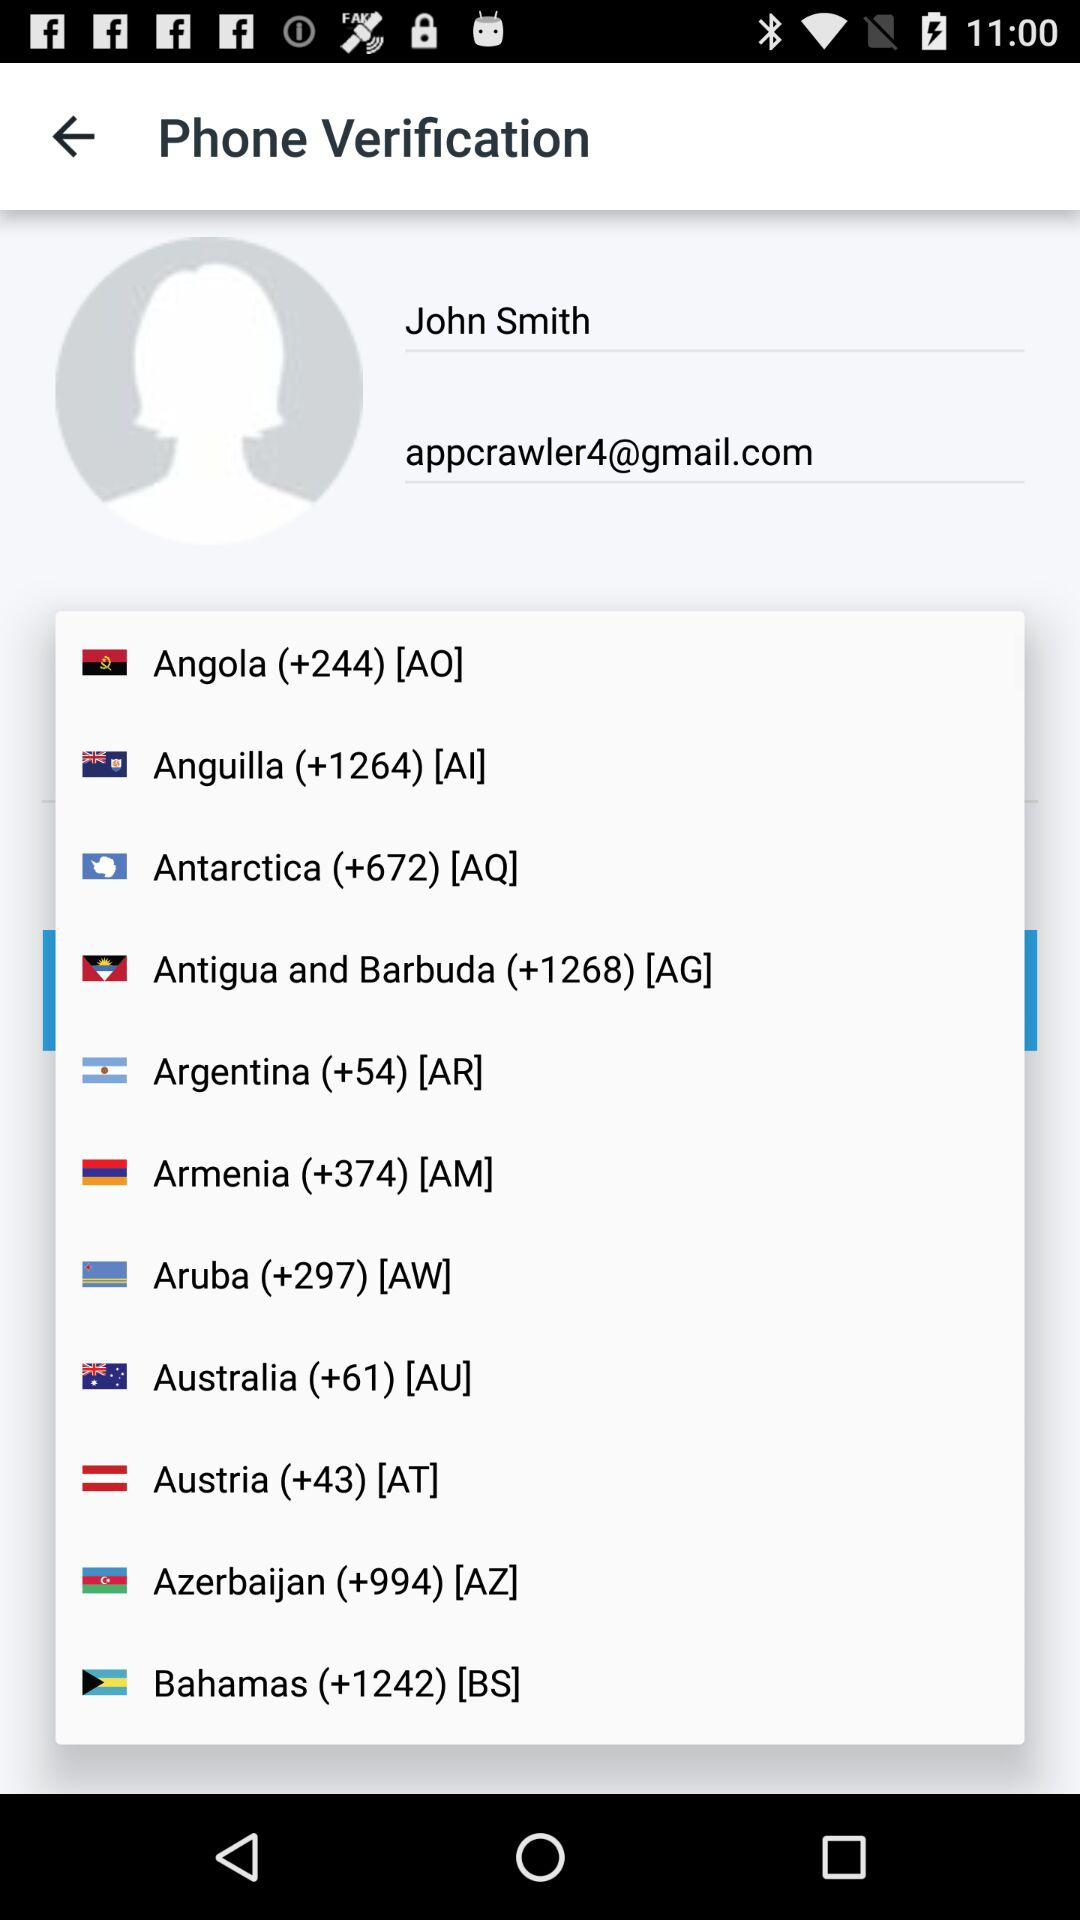What is the user's email address? The user's email address is appcrawler4@gmail.com. 